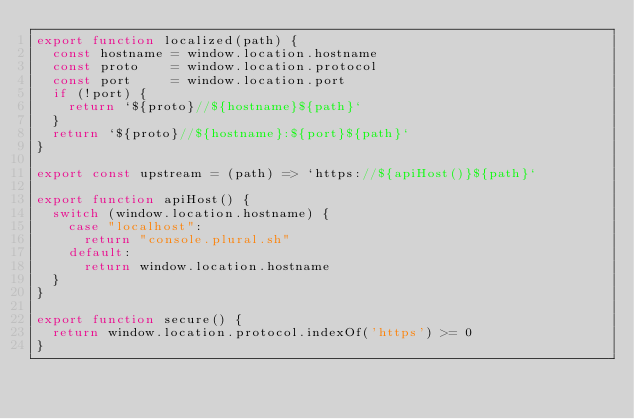Convert code to text. <code><loc_0><loc_0><loc_500><loc_500><_JavaScript_>export function localized(path) {
  const hostname = window.location.hostname
  const proto    = window.location.protocol
  const port     = window.location.port
  if (!port) {
    return `${proto}//${hostname}${path}`
  }
  return `${proto}//${hostname}:${port}${path}`
}

export const upstream = (path) => `https://${apiHost()}${path}`

export function apiHost() {
  switch (window.location.hostname) {
    case "localhost":
      return "console.plural.sh"
    default:
      return window.location.hostname
  }
}

export function secure() {
  return window.location.protocol.indexOf('https') >= 0
}</code> 